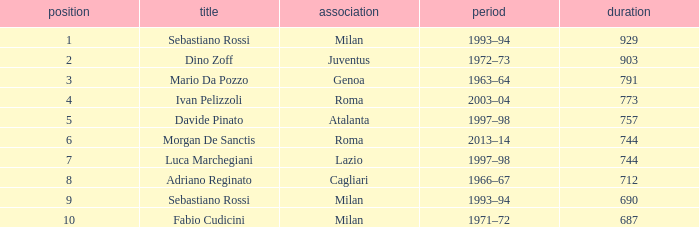What name is associated with a longer length than 903? Sebastiano Rossi. Would you be able to parse every entry in this table? {'header': ['position', 'title', 'association', 'period', 'duration'], 'rows': [['1', 'Sebastiano Rossi', 'Milan', '1993–94', '929'], ['2', 'Dino Zoff', 'Juventus', '1972–73', '903'], ['3', 'Mario Da Pozzo', 'Genoa', '1963–64', '791'], ['4', 'Ivan Pelizzoli', 'Roma', '2003–04', '773'], ['5', 'Davide Pinato', 'Atalanta', '1997–98', '757'], ['6', 'Morgan De Sanctis', 'Roma', '2013–14', '744'], ['7', 'Luca Marchegiani', 'Lazio', '1997–98', '744'], ['8', 'Adriano Reginato', 'Cagliari', '1966–67', '712'], ['9', 'Sebastiano Rossi', 'Milan', '1993–94', '690'], ['10', 'Fabio Cudicini', 'Milan', '1971–72', '687']]} 